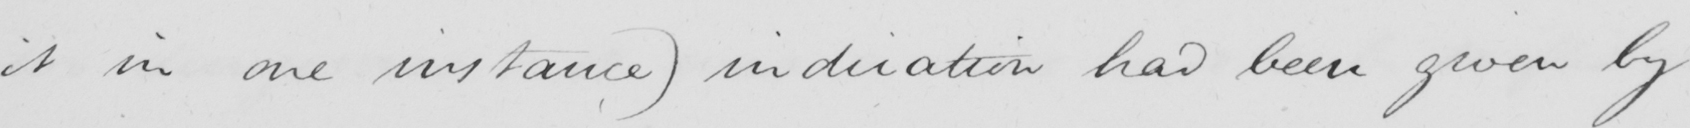Please provide the text content of this handwritten line. it in one instance )  indication had been given by 